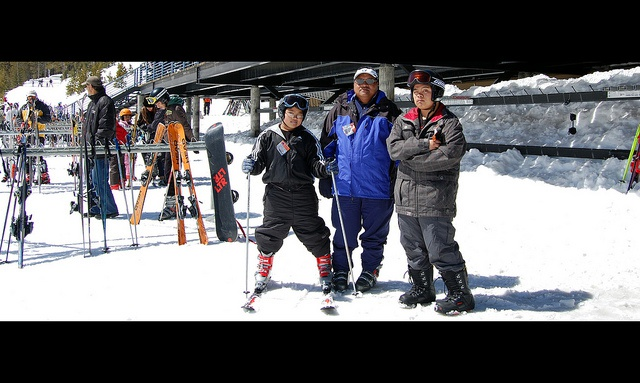Describe the objects in this image and their specific colors. I can see people in black, gray, and darkgray tones, people in black, navy, darkblue, and gray tones, people in black, gray, and white tones, people in black, gray, navy, and blue tones, and snowboard in black, gray, and darkblue tones in this image. 